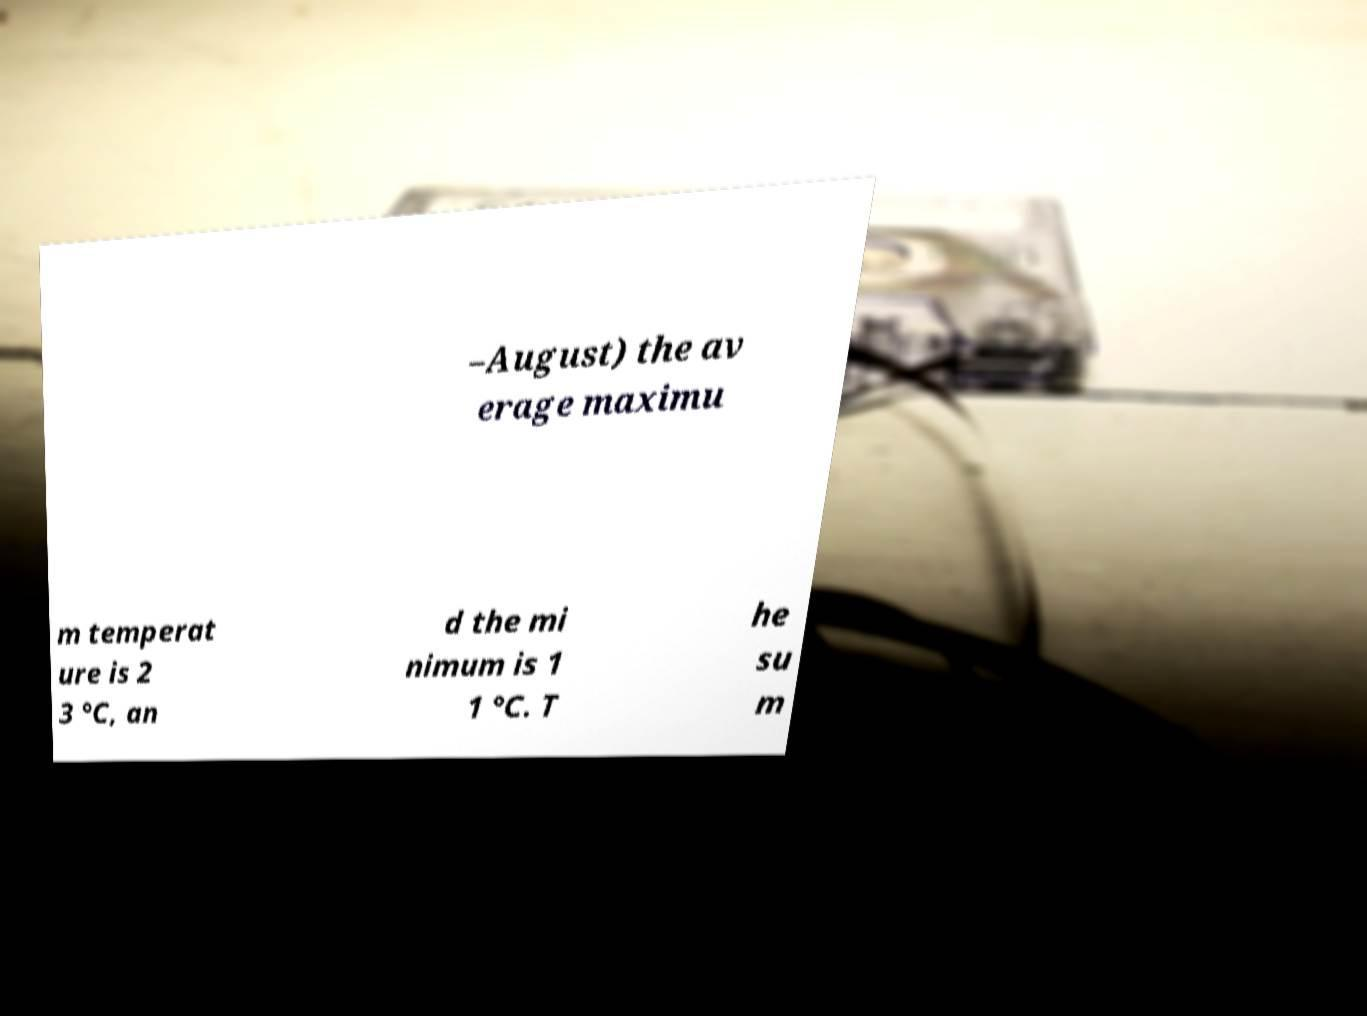Can you read and provide the text displayed in the image?This photo seems to have some interesting text. Can you extract and type it out for me? –August) the av erage maximu m temperat ure is 2 3 °C, an d the mi nimum is 1 1 °C. T he su m 